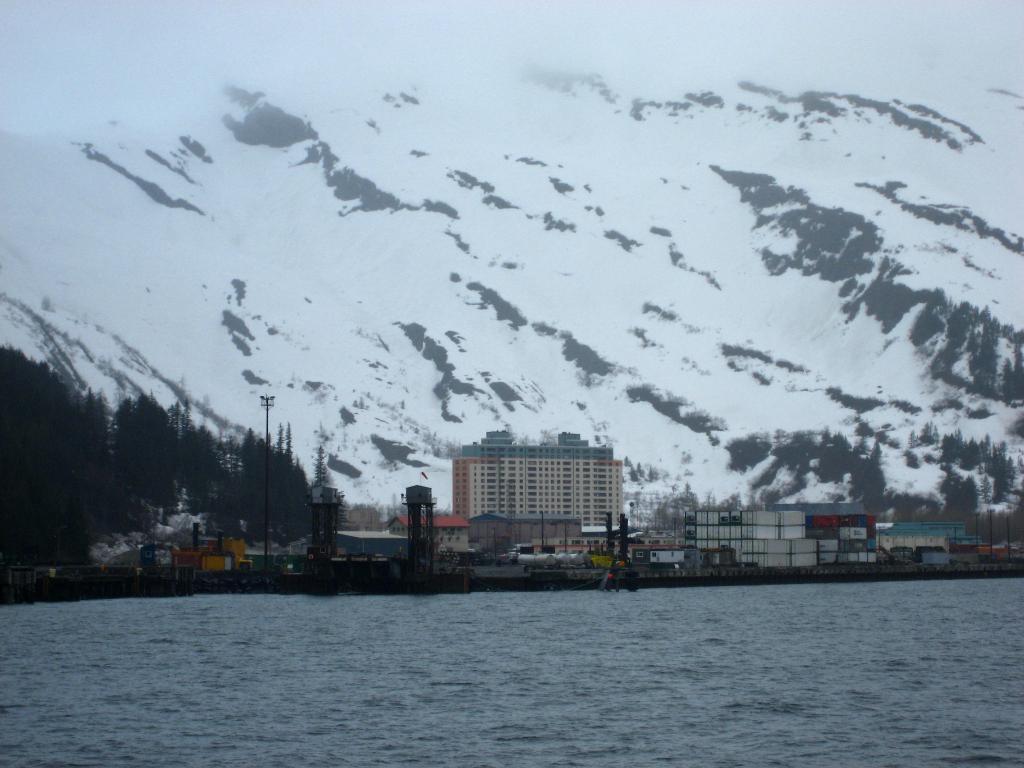Can you describe this image briefly? In the image at the bottom we can see water. In the background there are trees, poles, metal objects, buildings, houses, other objects and snow on the mountains and trees. 